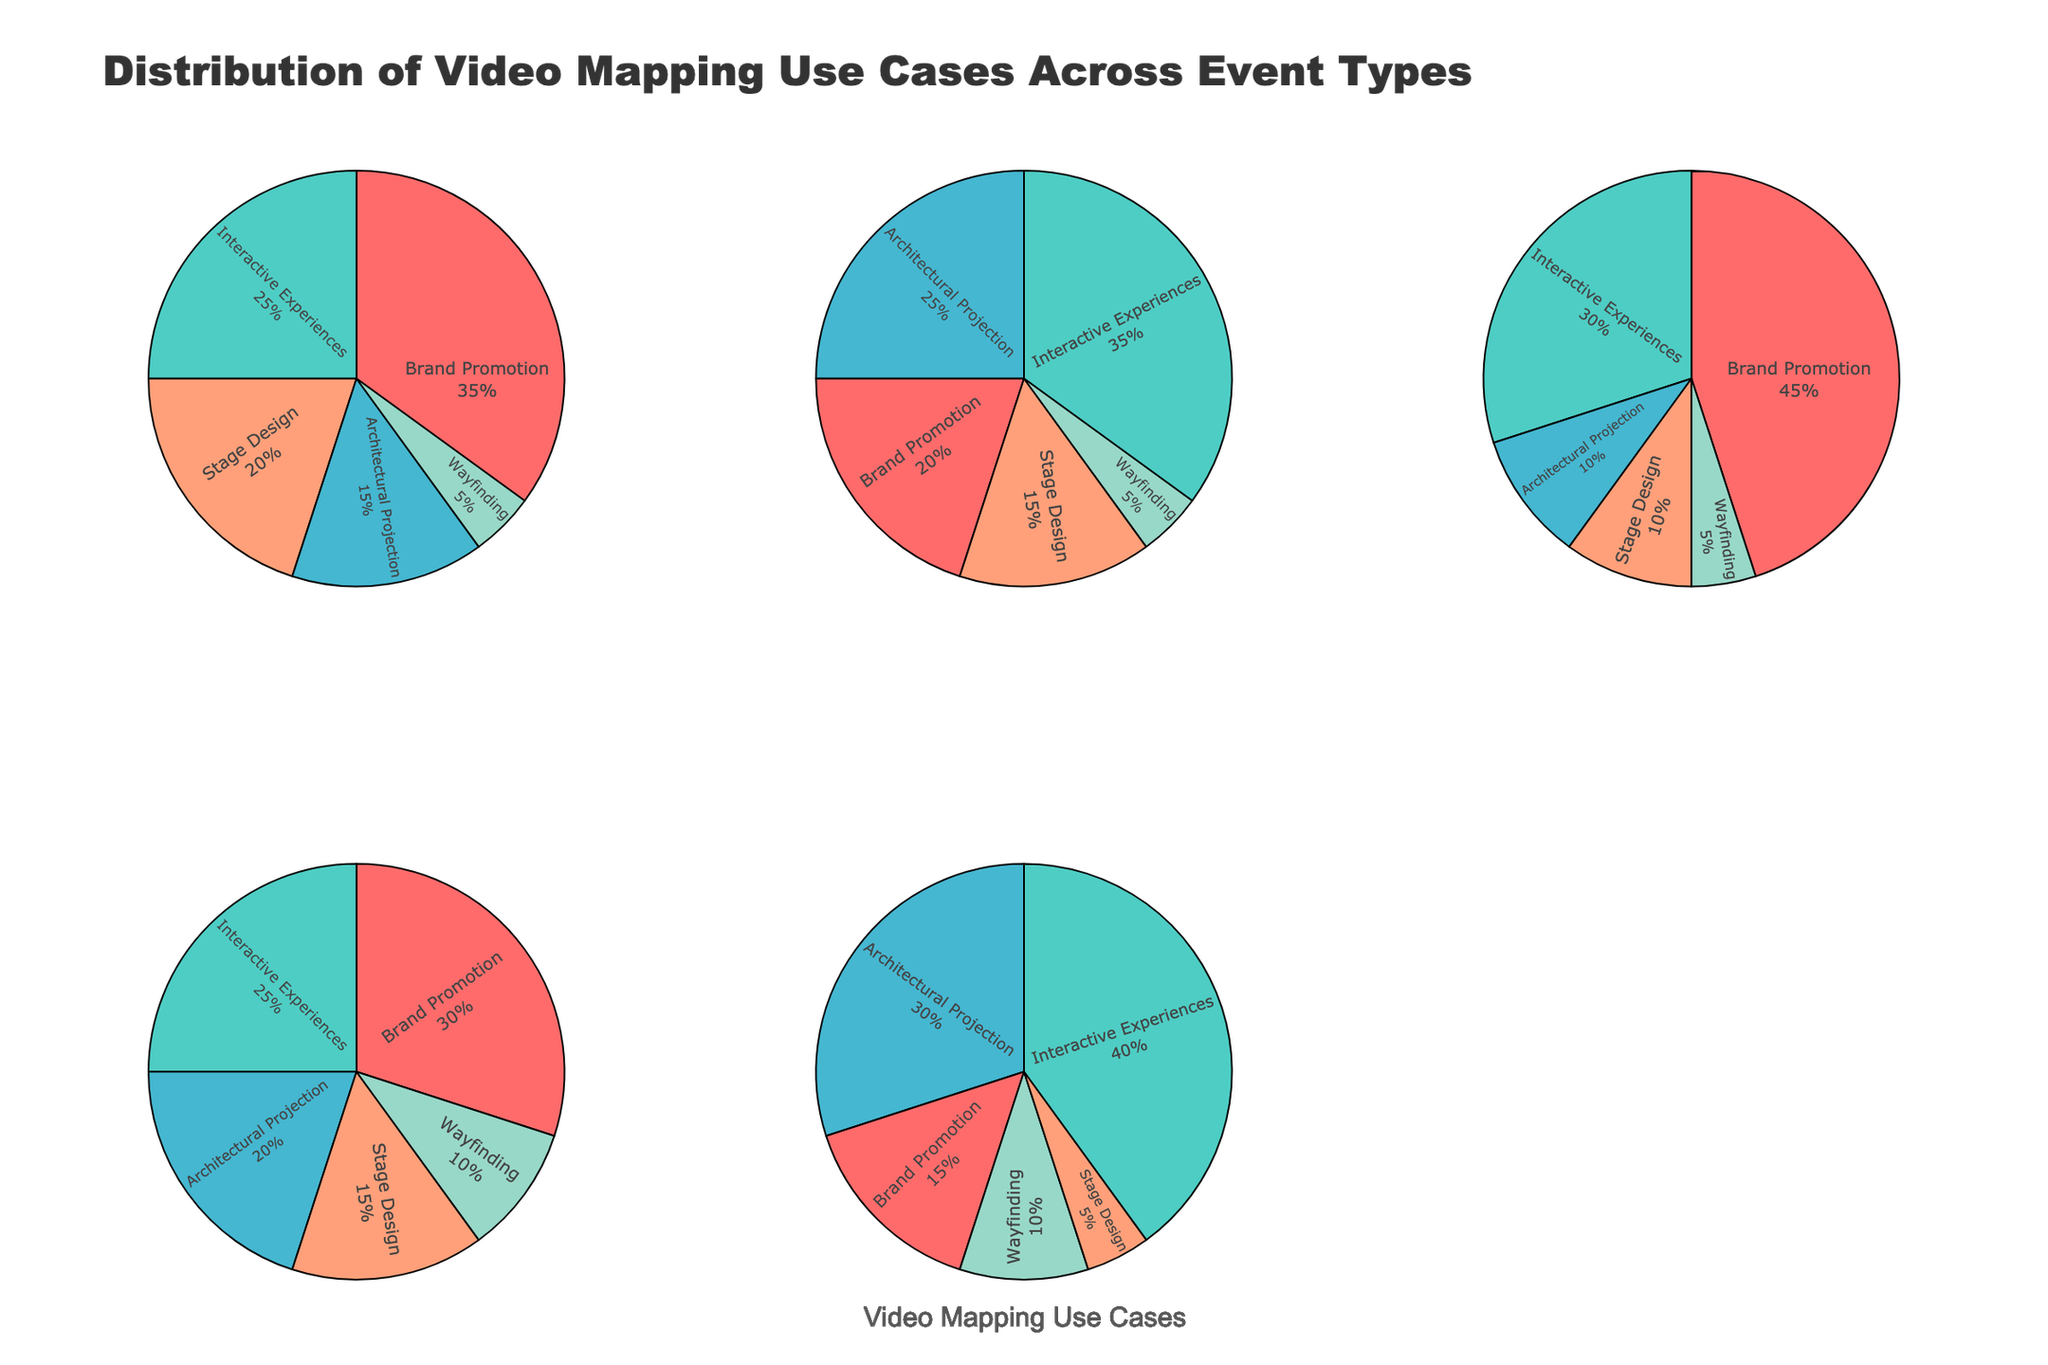What is the title of the figure? The title of the figure is usually displayed at the top, summarizing the main point of the visualization. In this case, it is evident from the plot layout.
Answer: Distribution of Video Mapping Use Cases Across Event Types Which event type has the highest proportion of Brand Promotion? To find this, look at the pie charts for each event type and identify the one with the largest section designated for Brand Promotion.
Answer: Product Launches What use case has the smallest segment in the Corporate Events pie chart? Look at the Corporate Events pie chart and find the smallest portion; the color will help distinguish it.
Answer: Wayfinding Among Music Festivals and Art Exhibitions, which has a higher percentage of Interactive Experiences? Compare the sections for Interactive Experiences in both Music Festivals and Art Exhibitions pie charts.
Answer: Art Exhibitions What is the total percentage of Wayfinding use cases across all event types? Add up the percentages corresponding to Wayfinding in all the individual pie charts. (5+5+5+10+10) = 35%
Answer: 35% Which two event types have the most balanced distribution of the five use cases? Look for event types where the pie chart sections are more evenly divided.
Answer: Corporate Events and Trade Shows How does the proportion of Stage Design in Product Launches compare to Music Festivals? Examine the size of the Stage Design segments in the respective pie charts; Product Launches appear to have a larger segment compared to Music Festivals.
Answer: Higher in Product Launches What are the colors used to differentiate the various use cases? Identify the distinct colors used in the pie charts to distinguish various video mapping use cases. The legend usually helps.
Answer: Red, Teal, Blue, Orange, Light Green In which event type is there the least difference between the highest and lowest use case proportions? Calculate the difference between the largest and smallest segments for each event type. The one with the smallest difference will be the result.
Answer: Corporate Events 